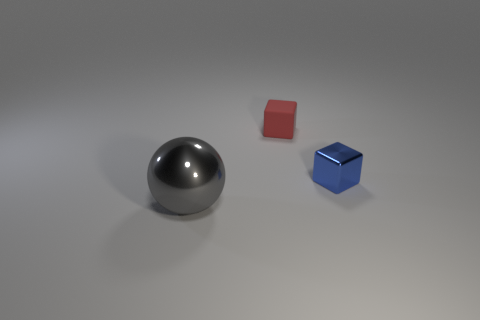Add 2 rubber things. How many objects exist? 5 Subtract all cubes. How many objects are left? 1 Add 3 red blocks. How many red blocks exist? 4 Subtract 0 red cylinders. How many objects are left? 3 Subtract all gray metal things. Subtract all gray things. How many objects are left? 1 Add 2 big gray spheres. How many big gray spheres are left? 3 